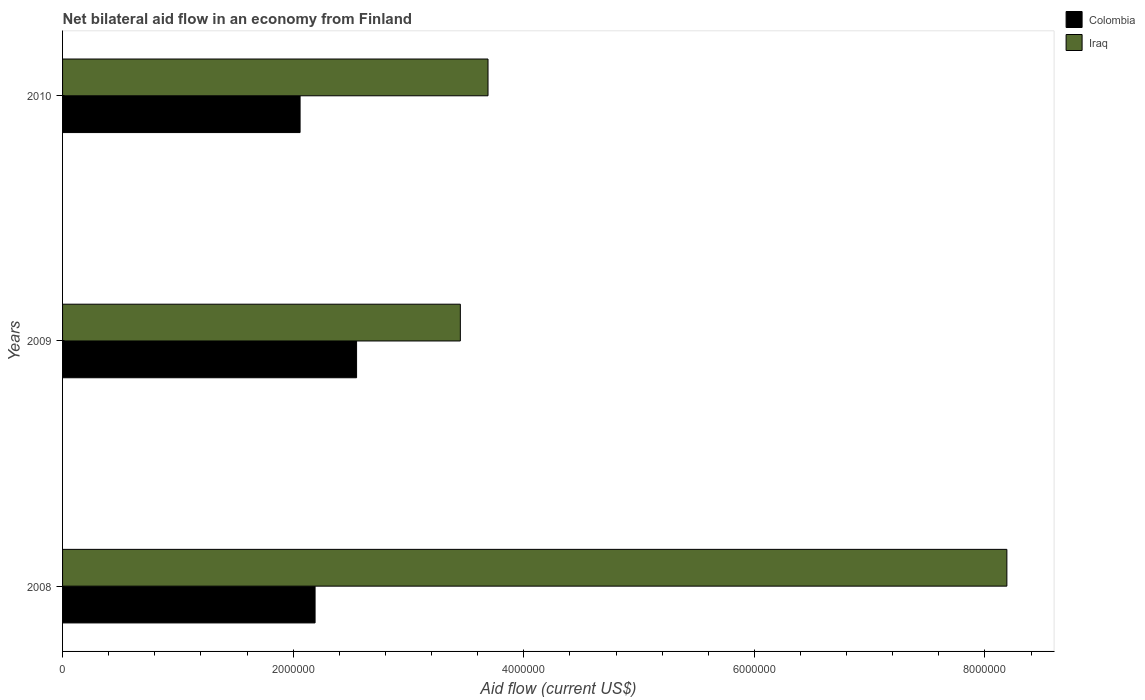How many different coloured bars are there?
Keep it short and to the point. 2. Are the number of bars on each tick of the Y-axis equal?
Keep it short and to the point. Yes. What is the label of the 2nd group of bars from the top?
Your response must be concise. 2009. In how many cases, is the number of bars for a given year not equal to the number of legend labels?
Provide a short and direct response. 0. What is the net bilateral aid flow in Colombia in 2008?
Give a very brief answer. 2.19e+06. Across all years, what is the maximum net bilateral aid flow in Colombia?
Make the answer very short. 2.55e+06. Across all years, what is the minimum net bilateral aid flow in Colombia?
Provide a succinct answer. 2.06e+06. In which year was the net bilateral aid flow in Iraq minimum?
Your response must be concise. 2009. What is the total net bilateral aid flow in Colombia in the graph?
Keep it short and to the point. 6.80e+06. What is the difference between the net bilateral aid flow in Colombia in 2010 and the net bilateral aid flow in Iraq in 2009?
Provide a succinct answer. -1.39e+06. What is the average net bilateral aid flow in Colombia per year?
Provide a succinct answer. 2.27e+06. In the year 2009, what is the difference between the net bilateral aid flow in Iraq and net bilateral aid flow in Colombia?
Give a very brief answer. 9.00e+05. In how many years, is the net bilateral aid flow in Colombia greater than 8000000 US$?
Provide a succinct answer. 0. What is the ratio of the net bilateral aid flow in Iraq in 2008 to that in 2010?
Your response must be concise. 2.22. Is the difference between the net bilateral aid flow in Iraq in 2008 and 2010 greater than the difference between the net bilateral aid flow in Colombia in 2008 and 2010?
Provide a succinct answer. Yes. What is the difference between the highest and the second highest net bilateral aid flow in Iraq?
Your answer should be very brief. 4.50e+06. What is the difference between the highest and the lowest net bilateral aid flow in Iraq?
Provide a short and direct response. 4.74e+06. In how many years, is the net bilateral aid flow in Iraq greater than the average net bilateral aid flow in Iraq taken over all years?
Provide a short and direct response. 1. What does the 1st bar from the top in 2009 represents?
Offer a terse response. Iraq. What does the 1st bar from the bottom in 2009 represents?
Offer a terse response. Colombia. How many bars are there?
Ensure brevity in your answer.  6. Are all the bars in the graph horizontal?
Your answer should be compact. Yes. What is the difference between two consecutive major ticks on the X-axis?
Your answer should be compact. 2.00e+06. Does the graph contain grids?
Ensure brevity in your answer.  No. What is the title of the graph?
Offer a terse response. Net bilateral aid flow in an economy from Finland. Does "Bermuda" appear as one of the legend labels in the graph?
Offer a very short reply. No. What is the label or title of the X-axis?
Provide a succinct answer. Aid flow (current US$). What is the label or title of the Y-axis?
Keep it short and to the point. Years. What is the Aid flow (current US$) of Colombia in 2008?
Ensure brevity in your answer.  2.19e+06. What is the Aid flow (current US$) in Iraq in 2008?
Keep it short and to the point. 8.19e+06. What is the Aid flow (current US$) in Colombia in 2009?
Keep it short and to the point. 2.55e+06. What is the Aid flow (current US$) in Iraq in 2009?
Give a very brief answer. 3.45e+06. What is the Aid flow (current US$) of Colombia in 2010?
Give a very brief answer. 2.06e+06. What is the Aid flow (current US$) of Iraq in 2010?
Your answer should be compact. 3.69e+06. Across all years, what is the maximum Aid flow (current US$) of Colombia?
Ensure brevity in your answer.  2.55e+06. Across all years, what is the maximum Aid flow (current US$) of Iraq?
Ensure brevity in your answer.  8.19e+06. Across all years, what is the minimum Aid flow (current US$) of Colombia?
Your answer should be compact. 2.06e+06. Across all years, what is the minimum Aid flow (current US$) of Iraq?
Your response must be concise. 3.45e+06. What is the total Aid flow (current US$) of Colombia in the graph?
Offer a very short reply. 6.80e+06. What is the total Aid flow (current US$) in Iraq in the graph?
Your response must be concise. 1.53e+07. What is the difference between the Aid flow (current US$) in Colombia in 2008 and that in 2009?
Provide a short and direct response. -3.60e+05. What is the difference between the Aid flow (current US$) in Iraq in 2008 and that in 2009?
Provide a short and direct response. 4.74e+06. What is the difference between the Aid flow (current US$) of Iraq in 2008 and that in 2010?
Your answer should be compact. 4.50e+06. What is the difference between the Aid flow (current US$) in Colombia in 2009 and that in 2010?
Offer a terse response. 4.90e+05. What is the difference between the Aid flow (current US$) of Colombia in 2008 and the Aid flow (current US$) of Iraq in 2009?
Give a very brief answer. -1.26e+06. What is the difference between the Aid flow (current US$) in Colombia in 2008 and the Aid flow (current US$) in Iraq in 2010?
Provide a short and direct response. -1.50e+06. What is the difference between the Aid flow (current US$) in Colombia in 2009 and the Aid flow (current US$) in Iraq in 2010?
Ensure brevity in your answer.  -1.14e+06. What is the average Aid flow (current US$) of Colombia per year?
Provide a succinct answer. 2.27e+06. What is the average Aid flow (current US$) in Iraq per year?
Your answer should be compact. 5.11e+06. In the year 2008, what is the difference between the Aid flow (current US$) of Colombia and Aid flow (current US$) of Iraq?
Your answer should be compact. -6.00e+06. In the year 2009, what is the difference between the Aid flow (current US$) in Colombia and Aid flow (current US$) in Iraq?
Your answer should be very brief. -9.00e+05. In the year 2010, what is the difference between the Aid flow (current US$) in Colombia and Aid flow (current US$) in Iraq?
Your response must be concise. -1.63e+06. What is the ratio of the Aid flow (current US$) of Colombia in 2008 to that in 2009?
Provide a short and direct response. 0.86. What is the ratio of the Aid flow (current US$) of Iraq in 2008 to that in 2009?
Offer a very short reply. 2.37. What is the ratio of the Aid flow (current US$) of Colombia in 2008 to that in 2010?
Offer a terse response. 1.06. What is the ratio of the Aid flow (current US$) of Iraq in 2008 to that in 2010?
Your answer should be compact. 2.22. What is the ratio of the Aid flow (current US$) of Colombia in 2009 to that in 2010?
Provide a short and direct response. 1.24. What is the ratio of the Aid flow (current US$) of Iraq in 2009 to that in 2010?
Your answer should be compact. 0.94. What is the difference between the highest and the second highest Aid flow (current US$) of Iraq?
Keep it short and to the point. 4.50e+06. What is the difference between the highest and the lowest Aid flow (current US$) of Iraq?
Make the answer very short. 4.74e+06. 